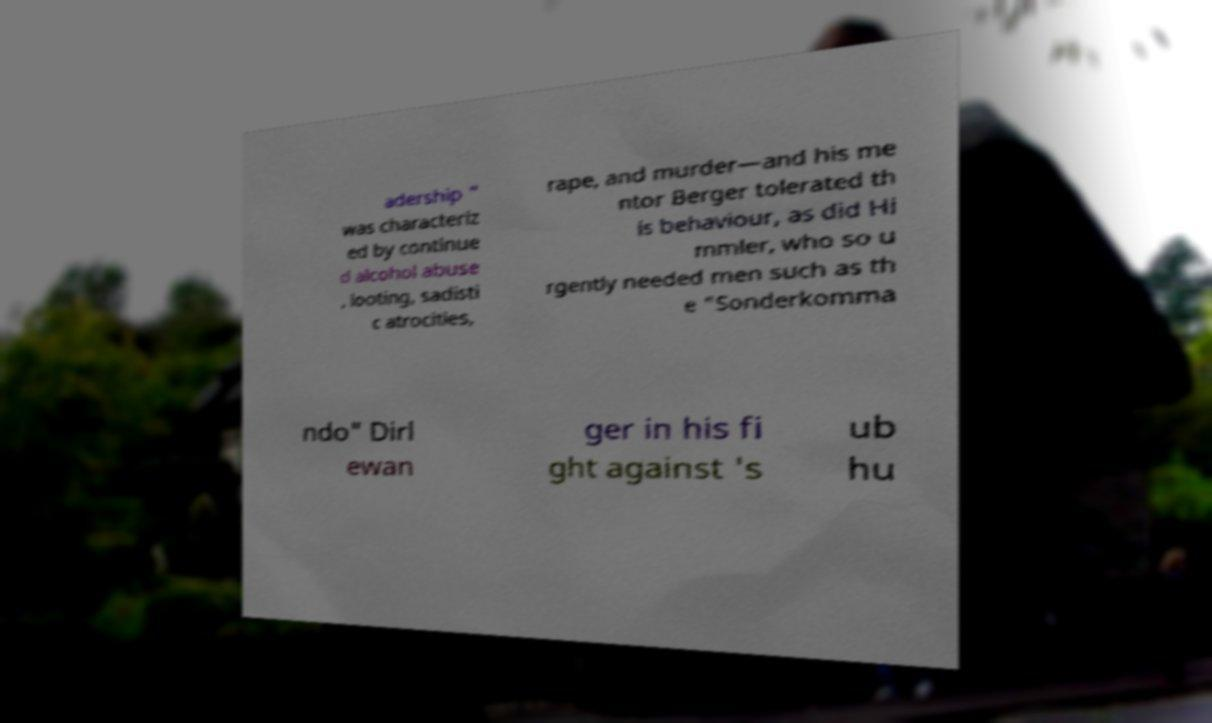Can you read and provide the text displayed in the image?This photo seems to have some interesting text. Can you extract and type it out for me? adership " was characteriz ed by continue d alcohol abuse , looting, sadisti c atrocities, rape, and murder—and his me ntor Berger tolerated th is behaviour, as did Hi mmler, who so u rgently needed men such as th e "Sonderkomma ndo" Dirl ewan ger in his fi ght against 's ub hu 